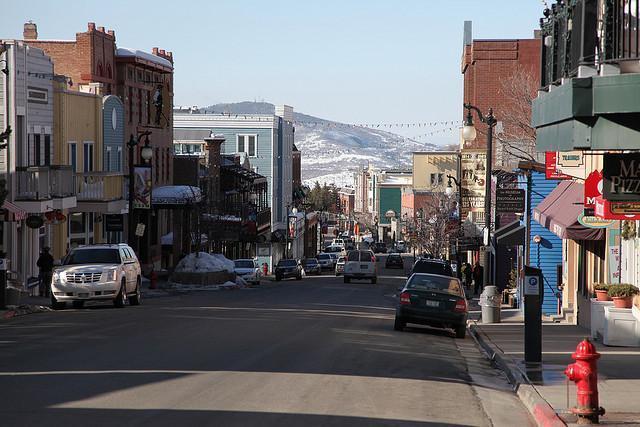How many trash cans are there?
Give a very brief answer. 1. How many cars are in the picture?
Give a very brief answer. 2. How many fire hydrants are in the photo?
Give a very brief answer. 1. How many bears are there?
Give a very brief answer. 0. 